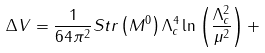<formula> <loc_0><loc_0><loc_500><loc_500>\Delta V = \frac { 1 } { 6 4 \pi ^ { 2 } } S t r \left ( M ^ { 0 } \right ) \Lambda _ { c } ^ { 4 } \ln \left ( \frac { \Lambda _ { c } ^ { 2 } } { \mu ^ { 2 } } \right ) +</formula> 